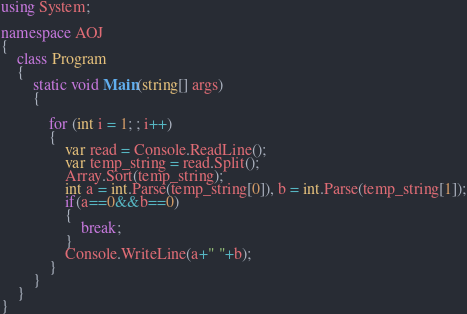<code> <loc_0><loc_0><loc_500><loc_500><_C#_>using System;

namespace AOJ
{
    class Program
    {
        static void Main(string[] args)
        {

            for (int i = 1; ; i++)
            {
                var read = Console.ReadLine();
                var temp_string = read.Split();
                Array.Sort(temp_string);
                int a = int.Parse(temp_string[0]), b = int.Parse(temp_string[1]);
                if(a==0&&b==0)
                {
                    break;
                }
                Console.WriteLine(a+" "+b);
            }
        }
    }
}</code> 